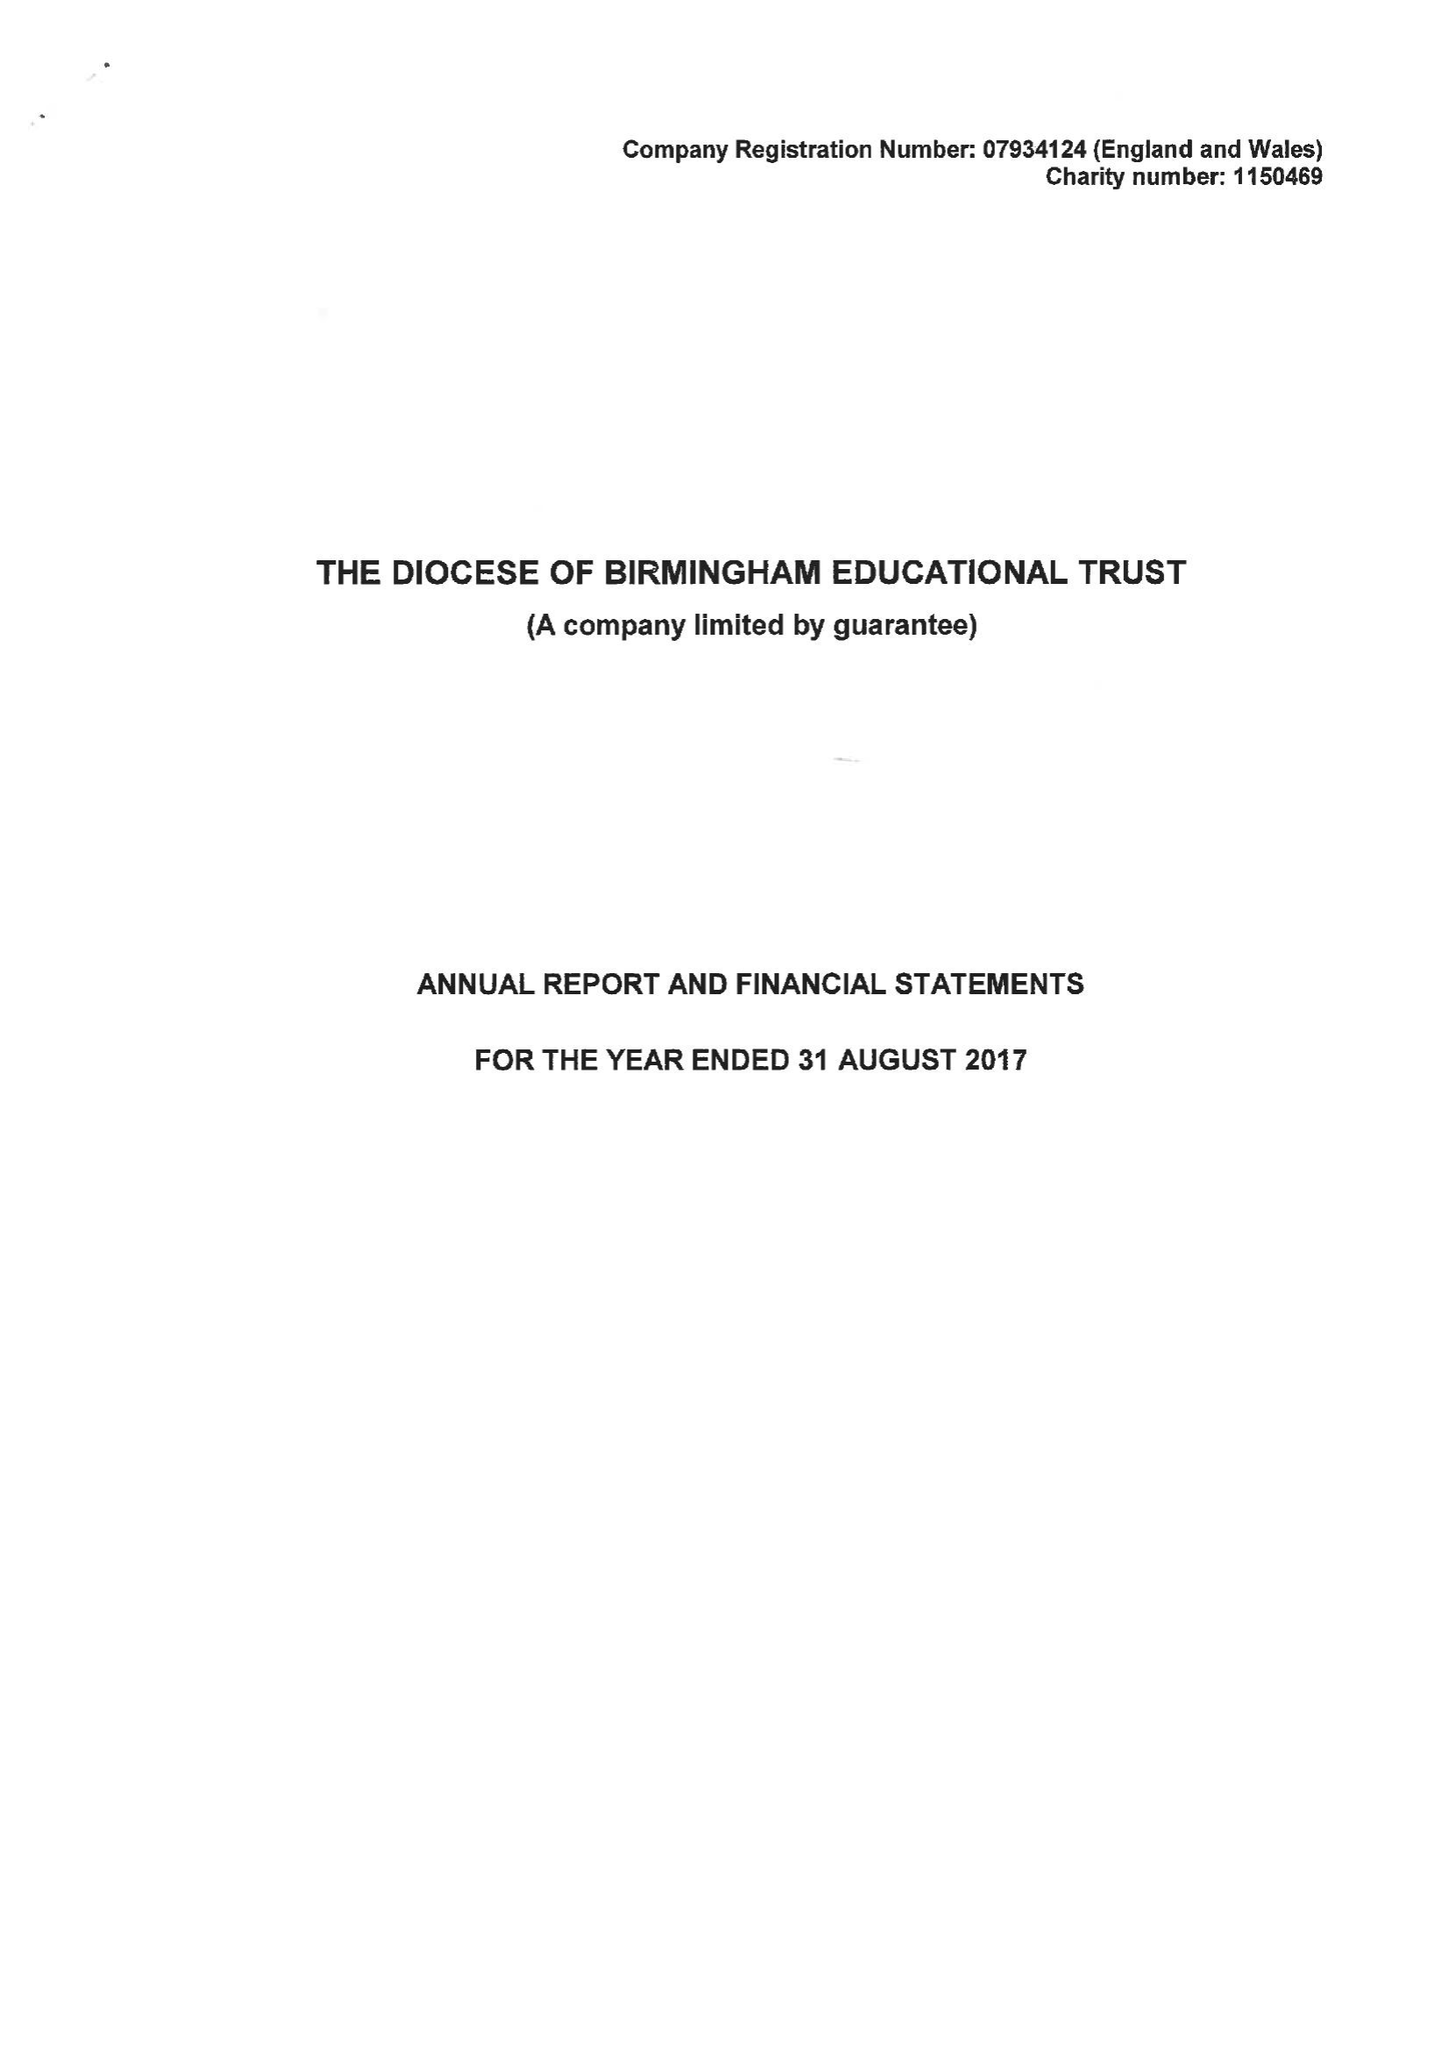What is the value for the report_date?
Answer the question using a single word or phrase. 2017-08-31 